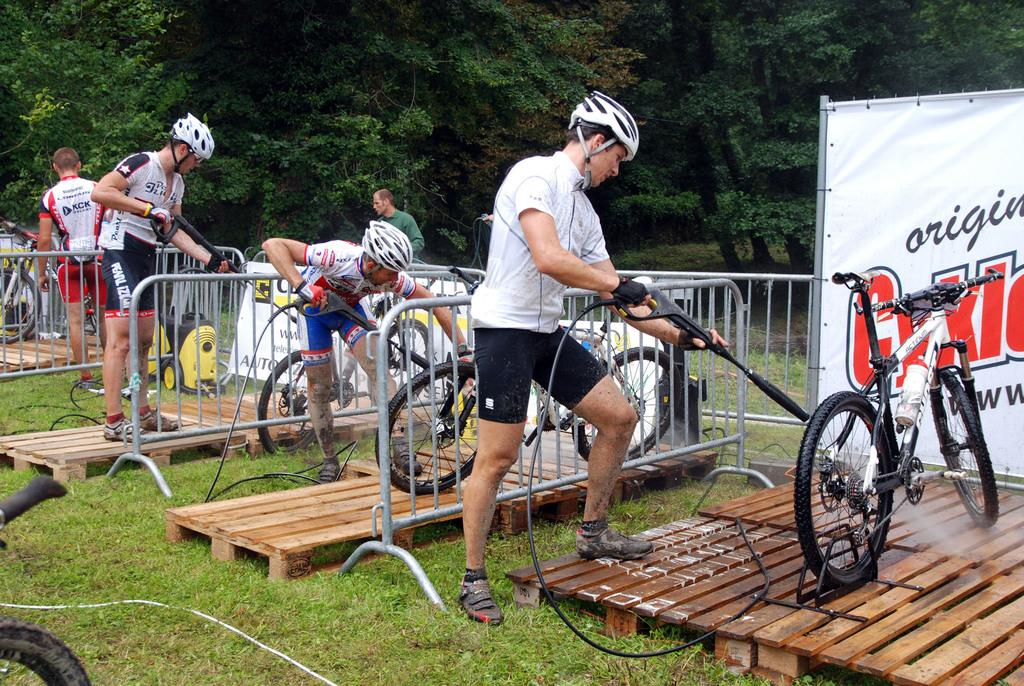How many people are in the image? There are people in the image, but the exact number is not specified. What are the people doing in the image? Some people are holding objects, and there are bicycles in the image, which suggests they might be participating in an event or activity. What can be seen in the background of the image? There are trees in the background of the image. What objects are present on the grass? There are wooden objects on the grass. Is there a snowball fight happening in the image? There is no mention of snow or a snowball fight in the image. The presence of trees in the background suggests a natural setting, but there is no indication of snow or a snowball fight. 